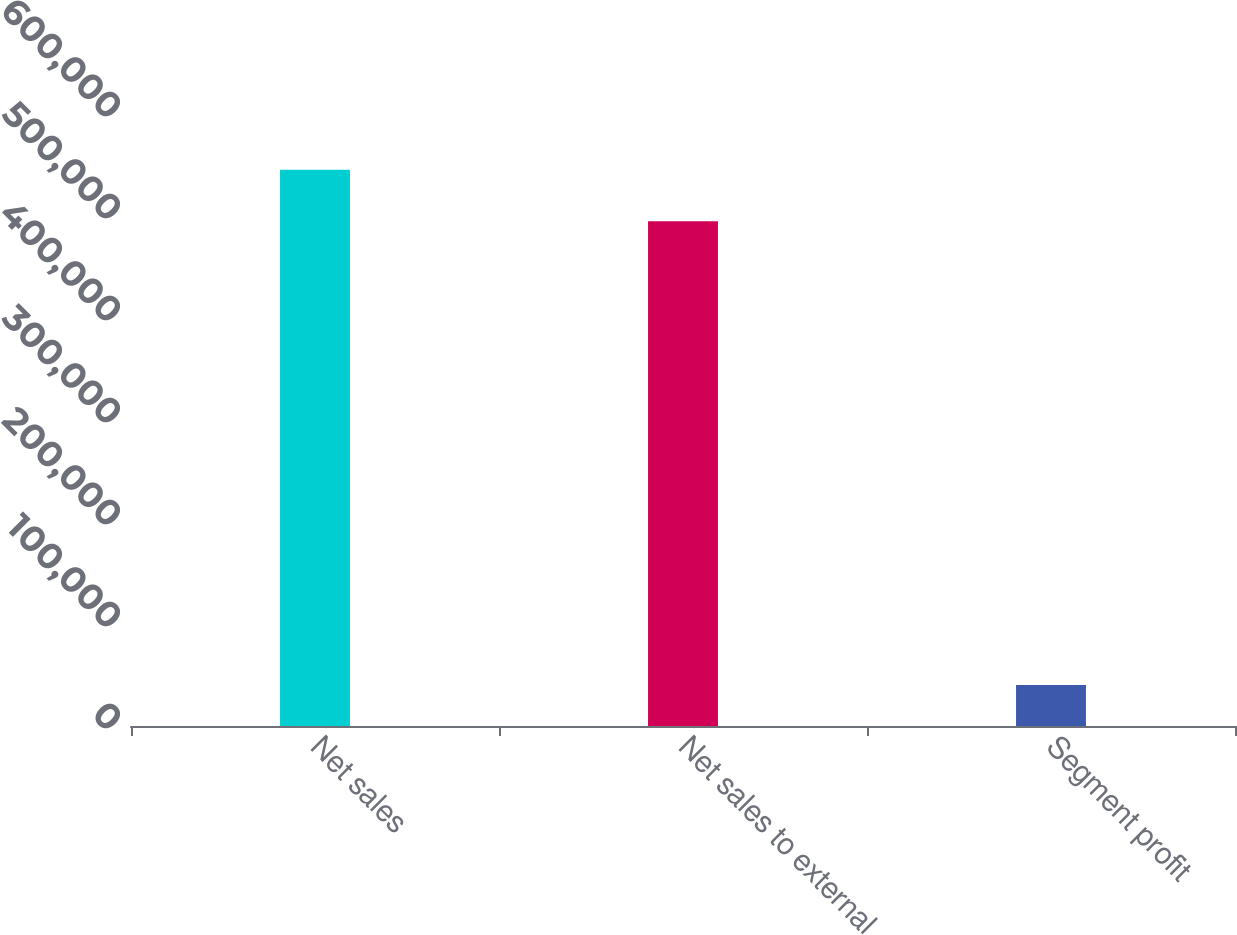Convert chart. <chart><loc_0><loc_0><loc_500><loc_500><bar_chart><fcel>Net sales<fcel>Net sales to external<fcel>Segment profit<nl><fcel>545439<fcel>494921<fcel>40185<nl></chart> 